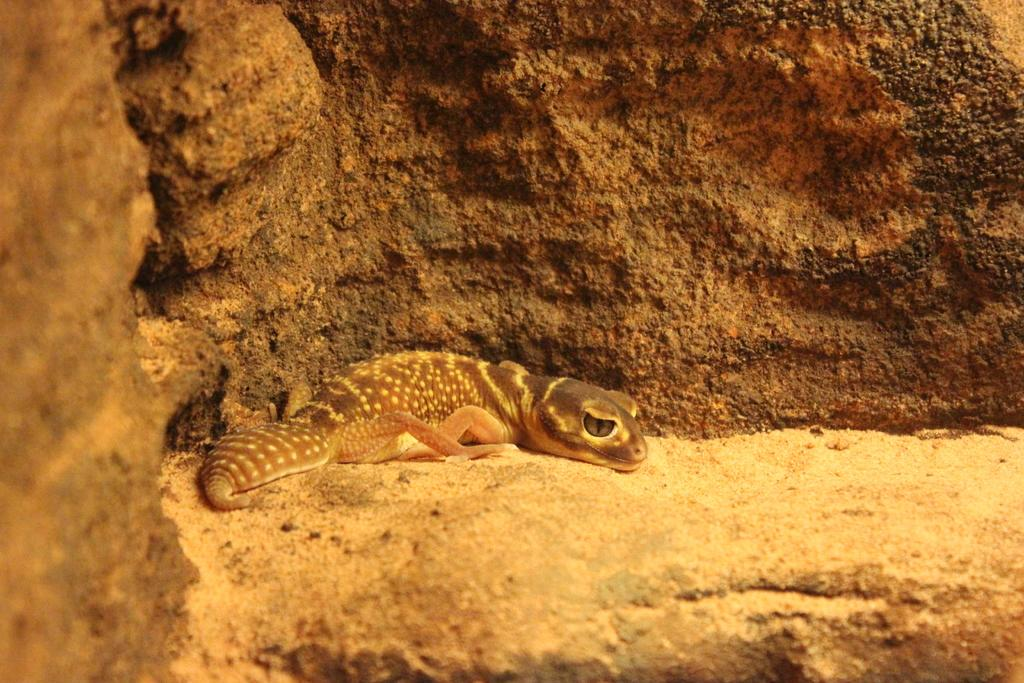What type of animal is present in the image? There is a lizard in the image. What can be seen in the background of the image? There is a wall in the background of the image. What type of apparatus is being used by the lizard in the image? There is no apparatus present in the image, and the lizard is not using any equipment. What type of flag is visible in the image? There is no flag present in the image; it only features a lizard and a wall. 